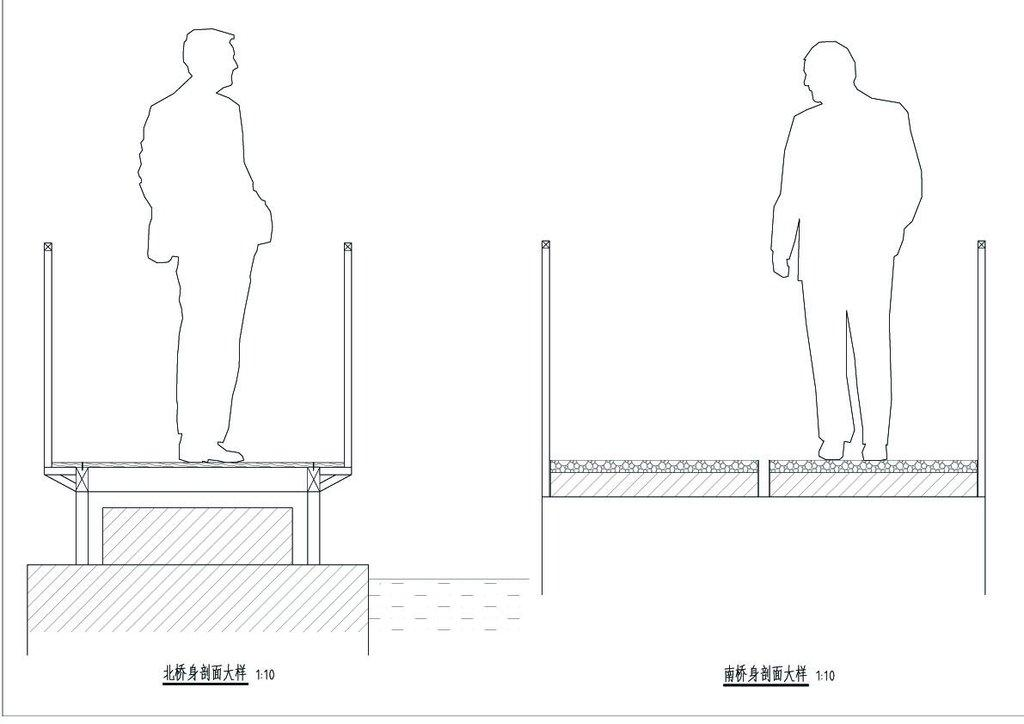What is the main subject of the image? The main subject of the image is an outline of a building. Are there any people in the image? Yes, there are two people in the image. Is there any text present in the image? Yes, there is some text at the bottom of the image. Can you describe the beggar in the image? There is no beggar present in the image. What type of beast can be seen interacting with the people in the image? There is no beast present in the image; only the building outline, two people, and text are visible. 